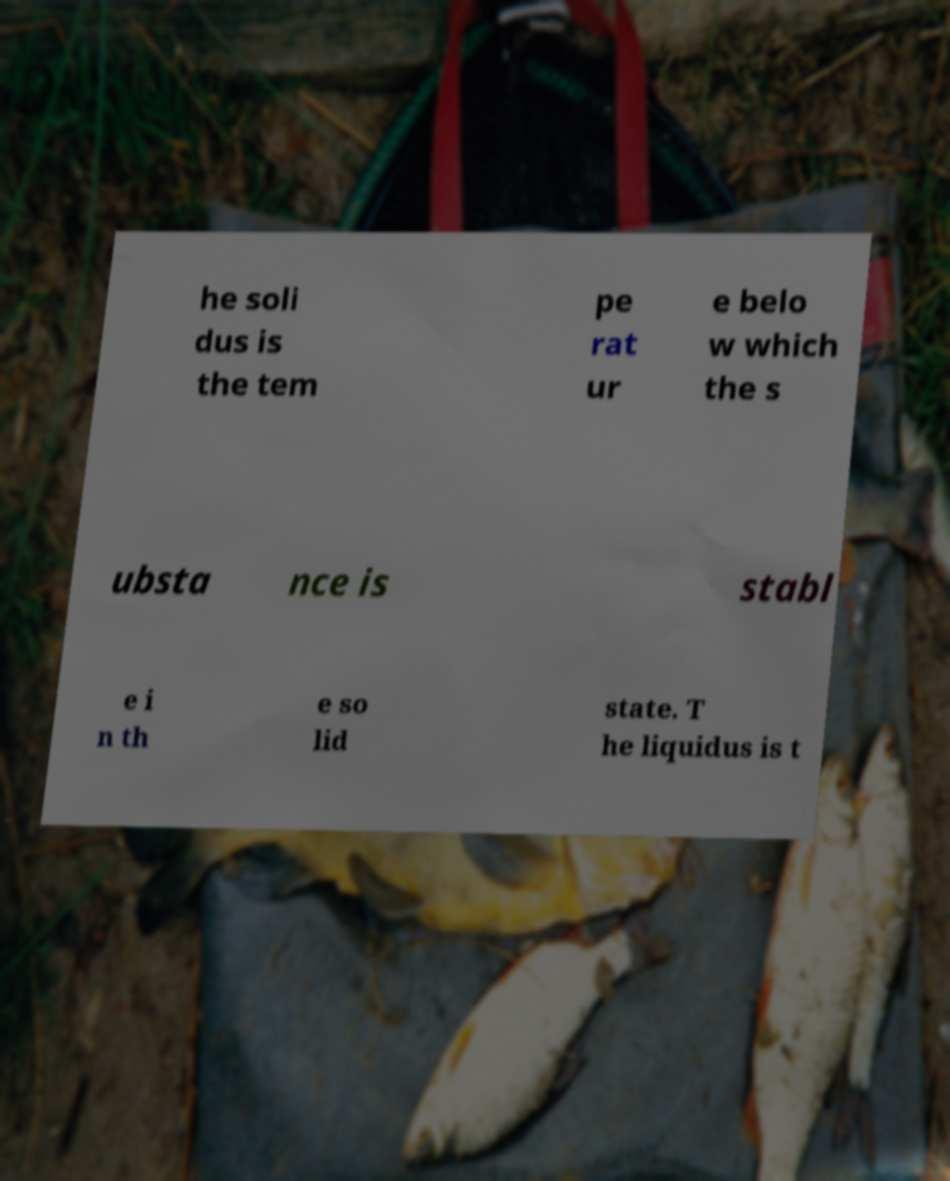Could you extract and type out the text from this image? he soli dus is the tem pe rat ur e belo w which the s ubsta nce is stabl e i n th e so lid state. T he liquidus is t 